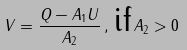<formula> <loc_0><loc_0><loc_500><loc_500>V = \frac { Q - A _ { 1 } U } { A _ { 2 } } \, , \, \text {if} \, A _ { 2 } > 0</formula> 